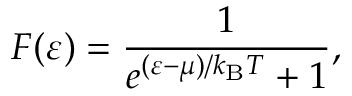Convert formula to latex. <formula><loc_0><loc_0><loc_500><loc_500>F ( \varepsilon ) = { \frac { 1 } { e ^ { ( \varepsilon - \mu ) / k _ { B } T } + 1 } } ,</formula> 